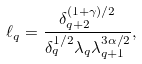Convert formula to latex. <formula><loc_0><loc_0><loc_500><loc_500>\ell _ { q } = \frac { \delta _ { q + 2 } ^ { ( 1 + \gamma ) / 2 } } { \delta _ { q } ^ { 1 / 2 } \lambda _ { q } \lambda _ { q + 1 } ^ { 3 \alpha / 2 } } ,</formula> 